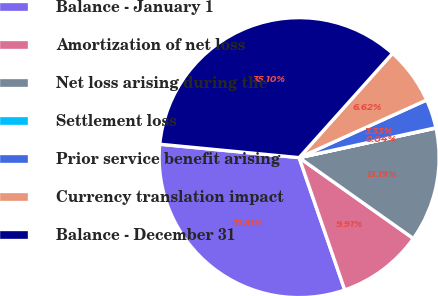Convert chart to OTSL. <chart><loc_0><loc_0><loc_500><loc_500><pie_chart><fcel>Balance - January 1<fcel>Amortization of net loss<fcel>Net loss arising during the<fcel>Settlement loss<fcel>Prior service benefit arising<fcel>Currency translation impact<fcel>Balance - December 31<nl><fcel>31.81%<fcel>9.91%<fcel>13.19%<fcel>0.04%<fcel>3.33%<fcel>6.62%<fcel>35.1%<nl></chart> 